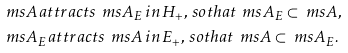<formula> <loc_0><loc_0><loc_500><loc_500>& \ m s { A } \, a t t r a c t s \, \ m s { A } _ { E } \, i n \, H _ { + } , \, s o t h a t \, \ m s { A } _ { E } \subset \ m s { A } , \\ & \ m s { A } _ { E } \, a t t r a c t s \, \ m s { A } \, i n \, E _ { + } , \, s o t h a t \, \ m s { A } \subset \ m s { A } _ { E } .</formula> 